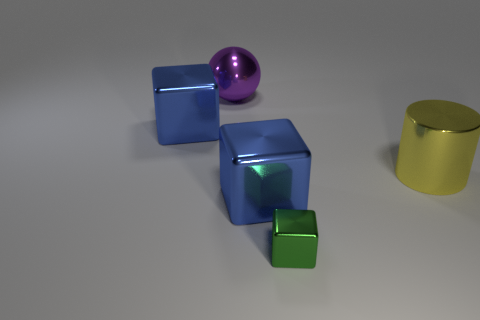Add 5 blue blocks. How many objects exist? 10 Subtract all cubes. How many objects are left? 2 Add 3 green blocks. How many green blocks are left? 4 Add 4 small green shiny things. How many small green shiny things exist? 5 Subtract 0 brown balls. How many objects are left? 5 Subtract all large purple shiny balls. Subtract all big purple matte cylinders. How many objects are left? 4 